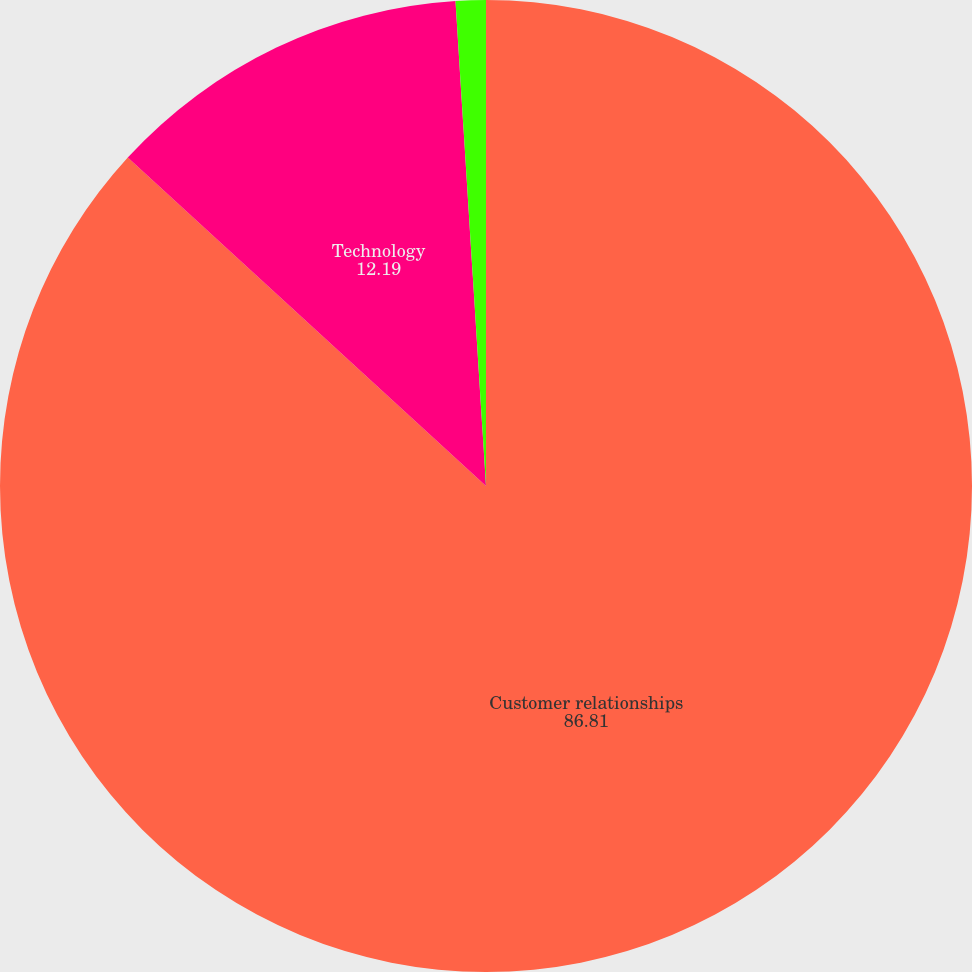Convert chart to OTSL. <chart><loc_0><loc_0><loc_500><loc_500><pie_chart><fcel>Customer relationships<fcel>Technology<fcel>Trademarks and tradenames<nl><fcel>86.81%<fcel>12.19%<fcel>1.0%<nl></chart> 